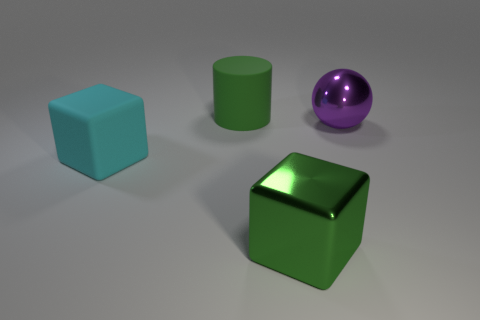There is a object that is the same color as the cylinder; what shape is it?
Offer a terse response. Cube. What number of large metal things are the same color as the metallic cube?
Your answer should be compact. 0. Do the green metallic cube and the green rubber object have the same size?
Provide a succinct answer. Yes. What is the big purple ball made of?
Provide a succinct answer. Metal. The big object that is made of the same material as the ball is what color?
Offer a terse response. Green. Does the large purple sphere have the same material as the big green object that is behind the large cyan rubber block?
Give a very brief answer. No. How many cyan cubes have the same material as the ball?
Your response must be concise. 0. What shape is the large thing on the right side of the large metallic block?
Provide a succinct answer. Sphere. Is the material of the green thing that is in front of the big purple sphere the same as the big thing that is behind the big shiny sphere?
Your answer should be compact. No. Is there another thing of the same shape as the big green metallic object?
Offer a terse response. Yes. 